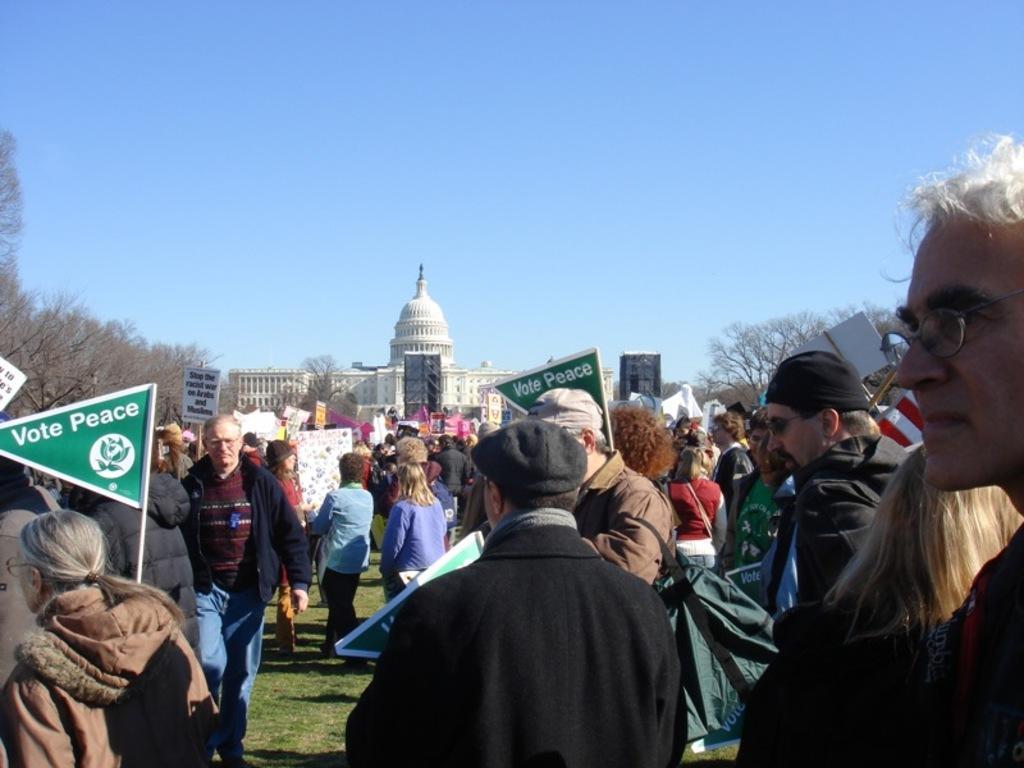Can you describe this image briefly? In this image, we can see some people standing and they are holding posters. We can see a building and there are some trees. At the top we can see the sky. 